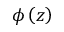Convert formula to latex. <formula><loc_0><loc_0><loc_500><loc_500>\phi \left ( z \right )</formula> 